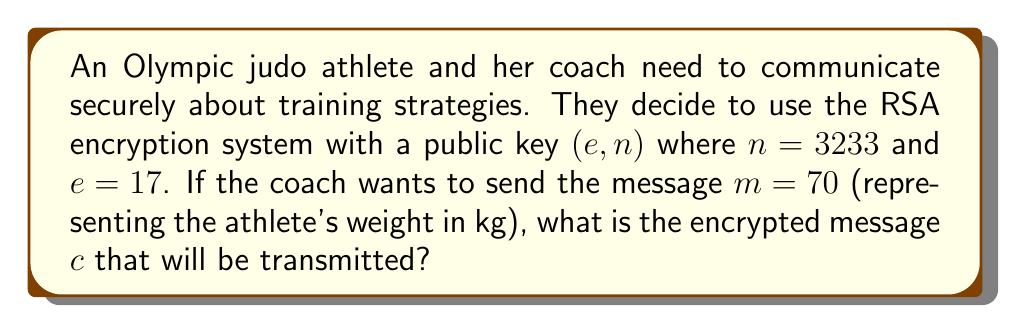Help me with this question. To encrypt the message using RSA, we follow these steps:

1) The encryption formula for RSA is:

   $c \equiv m^e \pmod{n}$

2) We are given:
   $m = 70$ (the plaintext message)
   $e = 17$ (the public exponent)
   $n = 3233$ (the modulus)

3) We need to calculate:

   $c \equiv 70^{17} \pmod{3233}$

4) This is a large exponentiation, so we'll use the square-and-multiply algorithm:

   $70^1 \equiv 70 \pmod{3233}$
   $70^2 \equiv 4900 \equiv 1667 \pmod{3233}$
   $70^4 \equiv 1667^2 \equiv 2778889 \equiv 2254 \pmod{3233}$
   $70^8 \equiv 2254^2 \equiv 5080516 \equiv 1600 \pmod{3233}$
   $70^{16} \equiv 1600^2 \equiv 2560000 \equiv 2401 \pmod{3233}$

5) Now, $17 = 16 + 1$, so:

   $70^{17} \equiv 70^{16} \cdot 70^1 \pmod{3233}$
   $\equiv 2401 \cdot 70 \pmod{3233}$
   $\equiv 168070 \pmod{3233}$
   $\equiv 2872 \pmod{3233}$

Therefore, the encrypted message $c$ is 2872.
Answer: 2872 